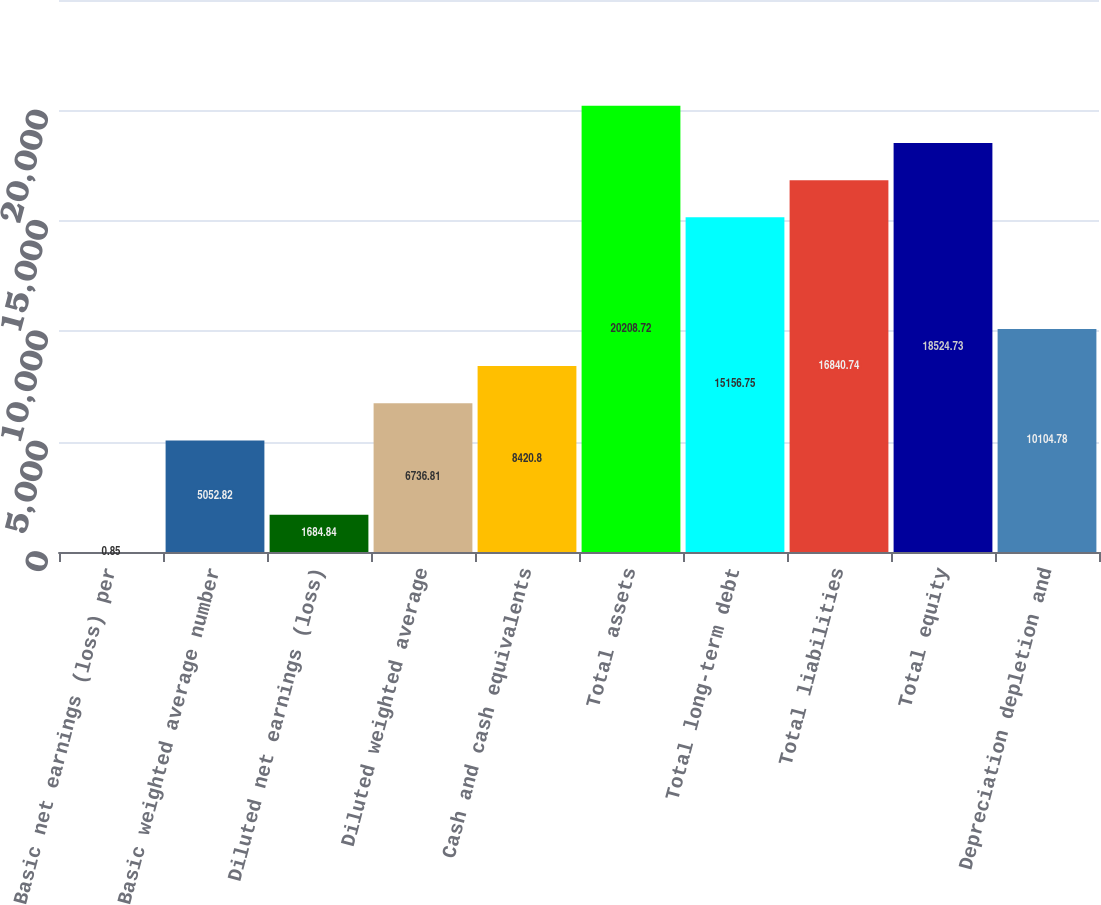Convert chart. <chart><loc_0><loc_0><loc_500><loc_500><bar_chart><fcel>Basic net earnings (loss) per<fcel>Basic weighted average number<fcel>Diluted net earnings (loss)<fcel>Diluted weighted average<fcel>Cash and cash equivalents<fcel>Total assets<fcel>Total long-term debt<fcel>Total liabilities<fcel>Total equity<fcel>Depreciation depletion and<nl><fcel>0.85<fcel>5052.82<fcel>1684.84<fcel>6736.81<fcel>8420.8<fcel>20208.7<fcel>15156.8<fcel>16840.7<fcel>18524.7<fcel>10104.8<nl></chart> 